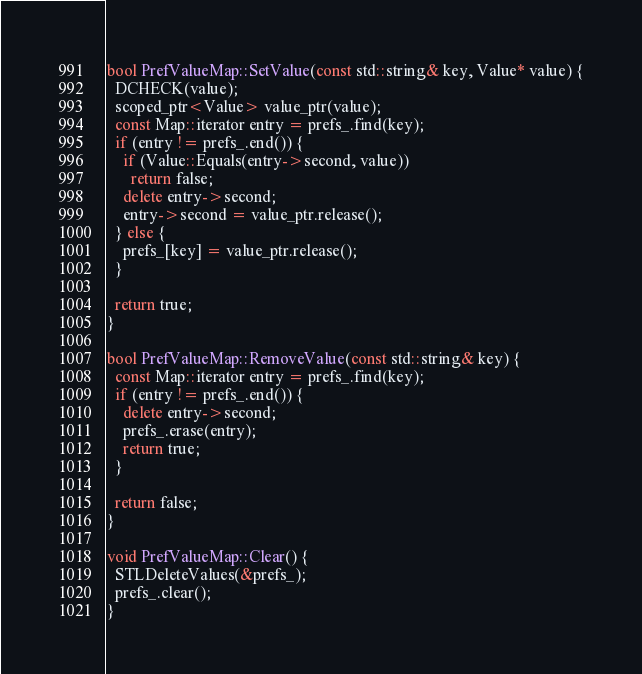<code> <loc_0><loc_0><loc_500><loc_500><_C++_>
bool PrefValueMap::SetValue(const std::string& key, Value* value) {
  DCHECK(value);
  scoped_ptr<Value> value_ptr(value);
  const Map::iterator entry = prefs_.find(key);
  if (entry != prefs_.end()) {
    if (Value::Equals(entry->second, value))
      return false;
    delete entry->second;
    entry->second = value_ptr.release();
  } else {
    prefs_[key] = value_ptr.release();
  }

  return true;
}

bool PrefValueMap::RemoveValue(const std::string& key) {
  const Map::iterator entry = prefs_.find(key);
  if (entry != prefs_.end()) {
    delete entry->second;
    prefs_.erase(entry);
    return true;
  }

  return false;
}

void PrefValueMap::Clear() {
  STLDeleteValues(&prefs_);
  prefs_.clear();
}
</code> 